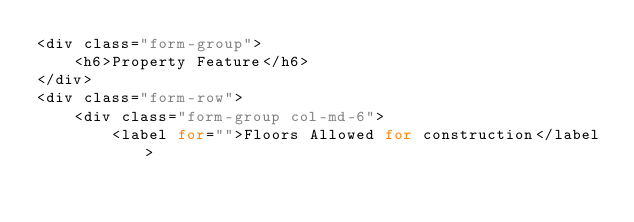<code> <loc_0><loc_0><loc_500><loc_500><_PHP_><div class="form-group">
    <h6>Property Feature</h6>
</div>
<div class="form-row">
    <div class="form-group col-md-6">
        <label for="">Floors Allowed for construction</label></code> 